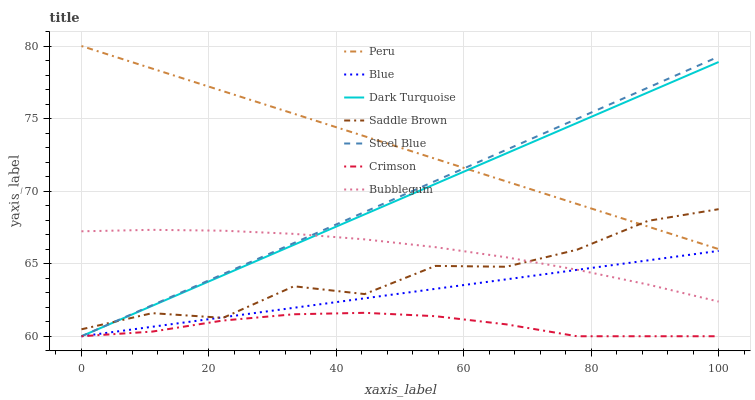Does Crimson have the minimum area under the curve?
Answer yes or no. Yes. Does Peru have the maximum area under the curve?
Answer yes or no. Yes. Does Dark Turquoise have the minimum area under the curve?
Answer yes or no. No. Does Dark Turquoise have the maximum area under the curve?
Answer yes or no. No. Is Dark Turquoise the smoothest?
Answer yes or no. Yes. Is Saddle Brown the roughest?
Answer yes or no. Yes. Is Steel Blue the smoothest?
Answer yes or no. No. Is Steel Blue the roughest?
Answer yes or no. No. Does Blue have the lowest value?
Answer yes or no. Yes. Does Bubblegum have the lowest value?
Answer yes or no. No. Does Peru have the highest value?
Answer yes or no. Yes. Does Dark Turquoise have the highest value?
Answer yes or no. No. Is Crimson less than Saddle Brown?
Answer yes or no. Yes. Is Saddle Brown greater than Crimson?
Answer yes or no. Yes. Does Bubblegum intersect Steel Blue?
Answer yes or no. Yes. Is Bubblegum less than Steel Blue?
Answer yes or no. No. Is Bubblegum greater than Steel Blue?
Answer yes or no. No. Does Crimson intersect Saddle Brown?
Answer yes or no. No. 